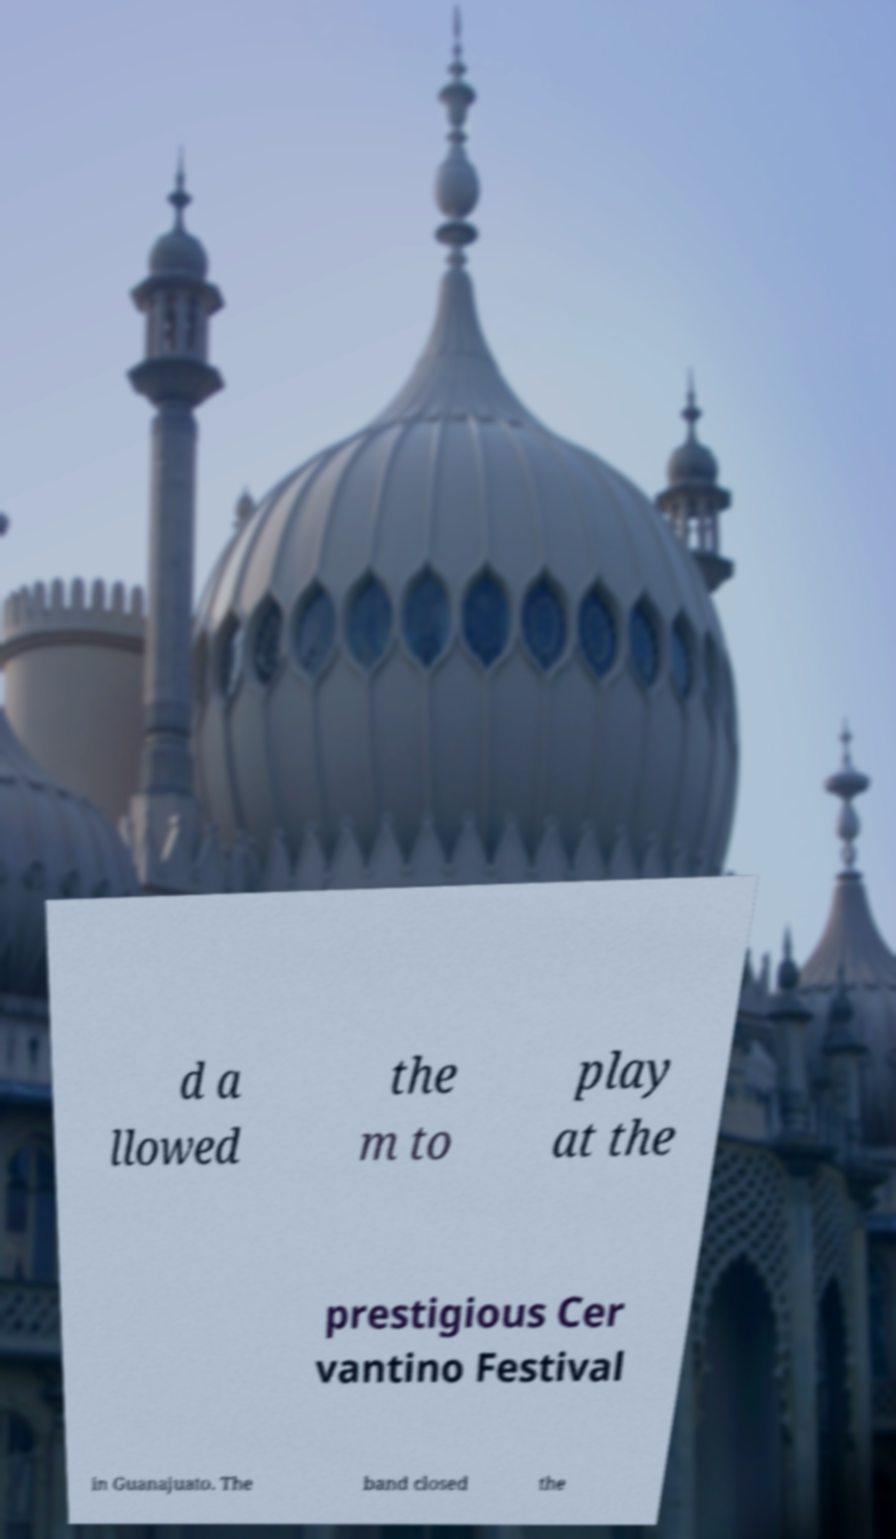I need the written content from this picture converted into text. Can you do that? d a llowed the m to play at the prestigious Cer vantino Festival in Guanajuato. The band closed the 